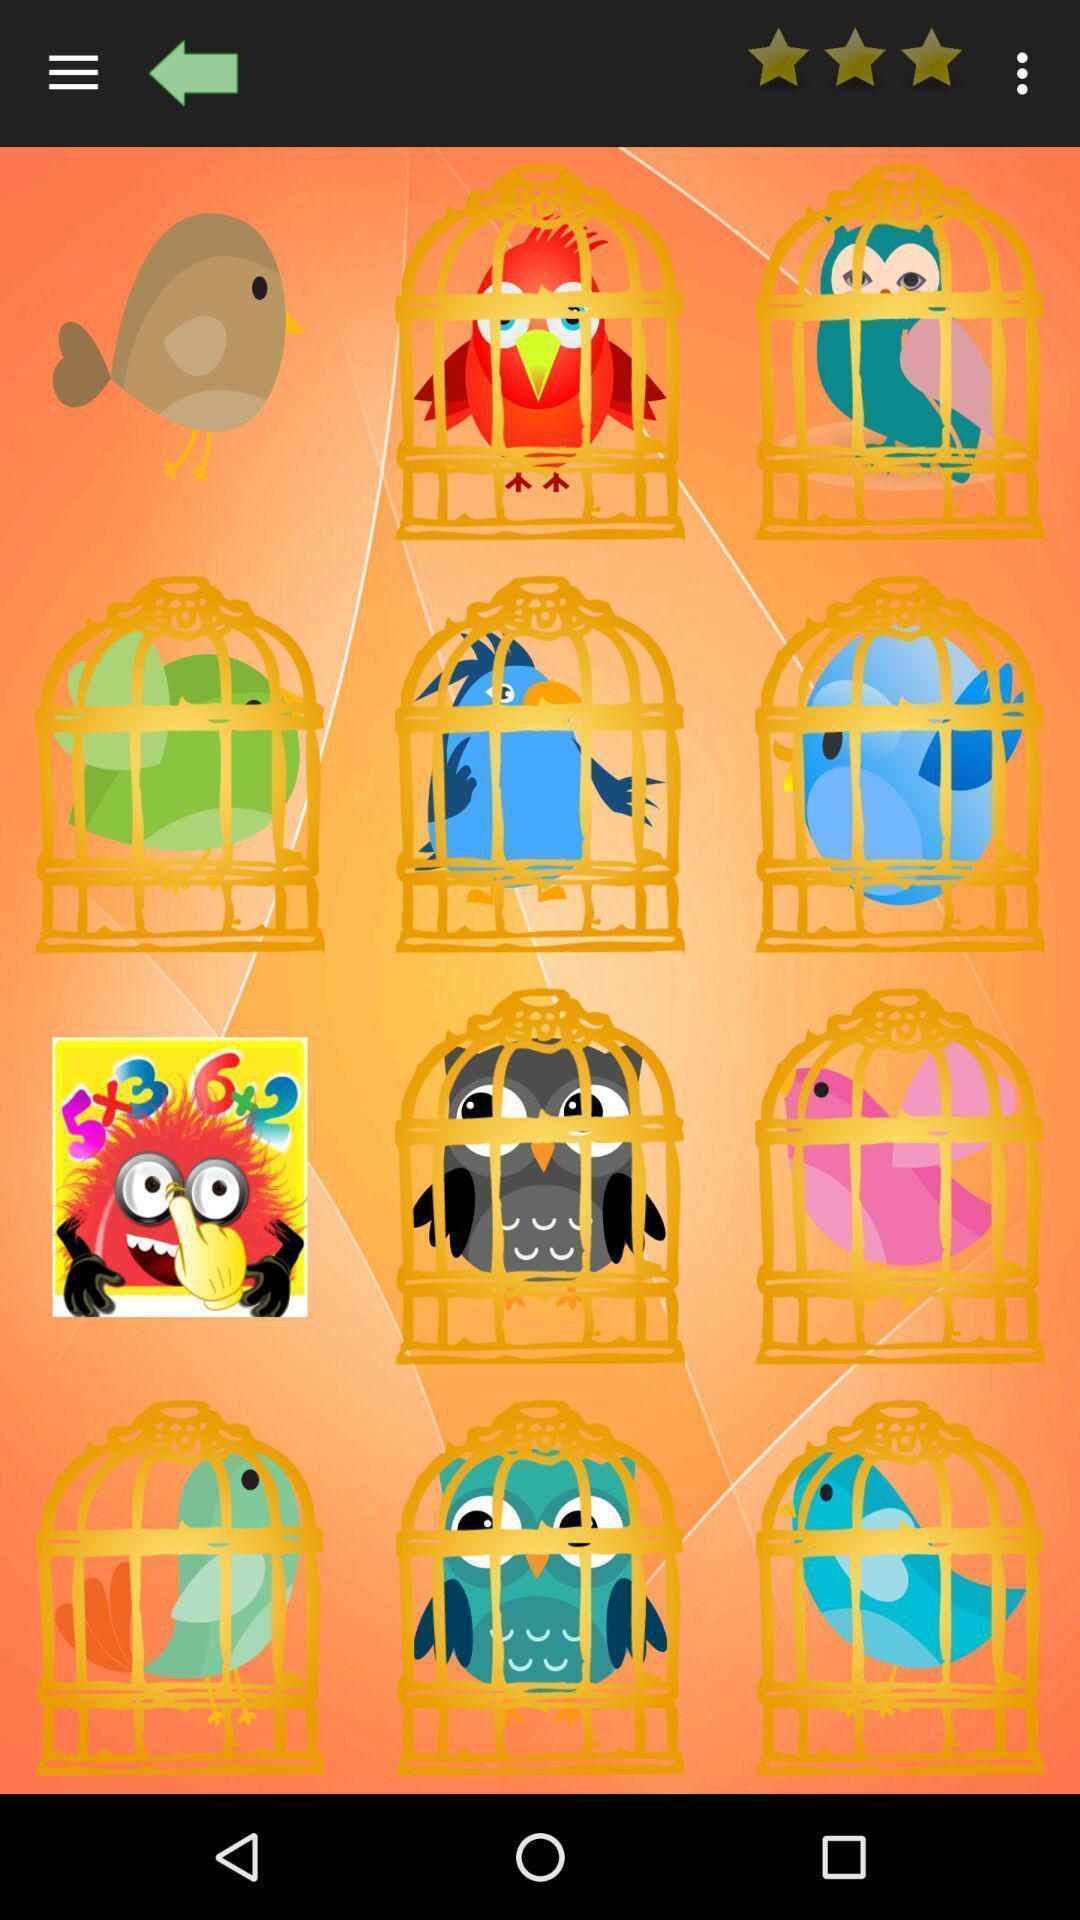Describe the content in this image. Screen showing page. 